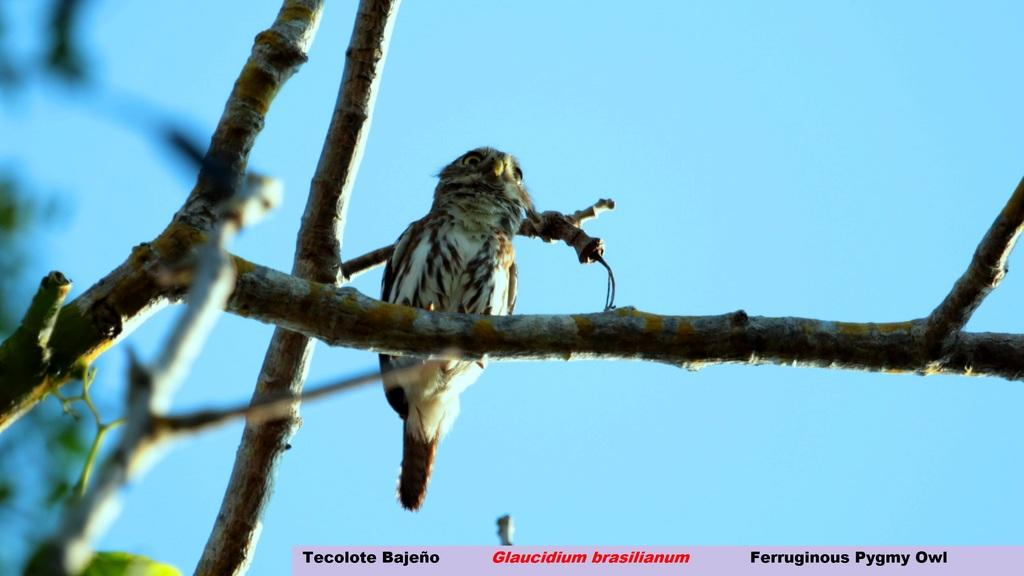What type of animal can be seen in the image? There is a bird in the image. Where is the bird located in the image? The bird is on the branches of a tree. What can be seen in the background of the image? The sky is visible in the background of the image. What type of note is the bird holding in its beak in the image? There is no note present in the image; the bird is simply perched on the branches of a tree. 